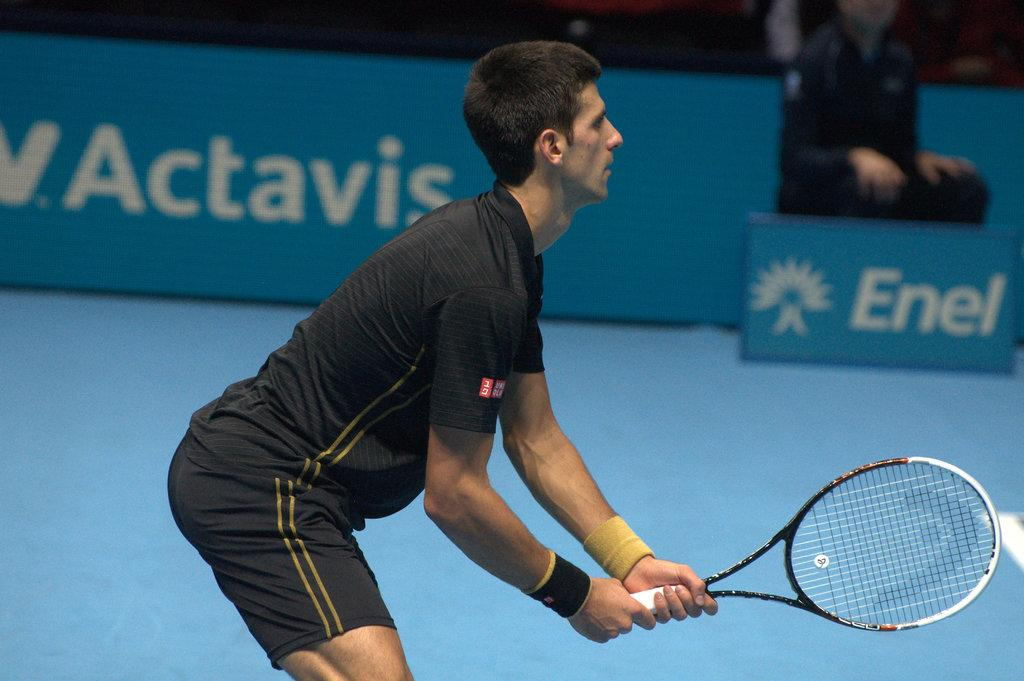What sport is Djokovic playing in the image? Djokovic is playing tennis in the image. What equipment is Djokovic using to play tennis? Djokovic is holding a tennis bat in the image. Can you describe the background of the image? There is a person sitting in the background of the image. What type of chain is Djokovic wearing in the image? There is no chain visible on Djokovic in the image. 